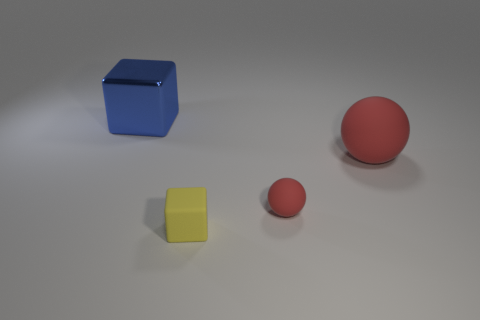Add 4 small yellow metallic things. How many objects exist? 8 Subtract all big metallic cubes. Subtract all blue metallic objects. How many objects are left? 2 Add 2 large rubber objects. How many large rubber objects are left? 3 Add 1 big blue things. How many big blue things exist? 2 Subtract 0 cyan cylinders. How many objects are left? 4 